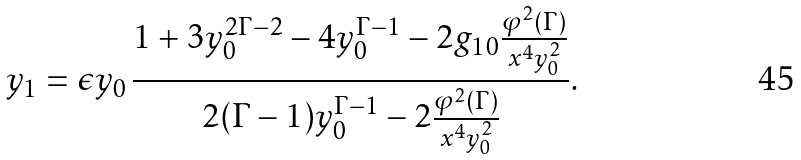Convert formula to latex. <formula><loc_0><loc_0><loc_500><loc_500>y _ { 1 } = \epsilon y _ { 0 } \, \frac { 1 + 3 y _ { 0 } ^ { 2 \Gamma - 2 } - 4 y _ { 0 } ^ { \Gamma - 1 } - 2 g _ { 1 0 } \frac { \varphi ^ { 2 } ( \Gamma ) } { x ^ { 4 } y _ { 0 } ^ { 2 } } } { 2 ( \Gamma - 1 ) y _ { 0 } ^ { \Gamma - 1 } - 2 \frac { \varphi ^ { 2 } ( \Gamma ) } { x ^ { 4 } y _ { 0 } ^ { 2 } } } .</formula> 